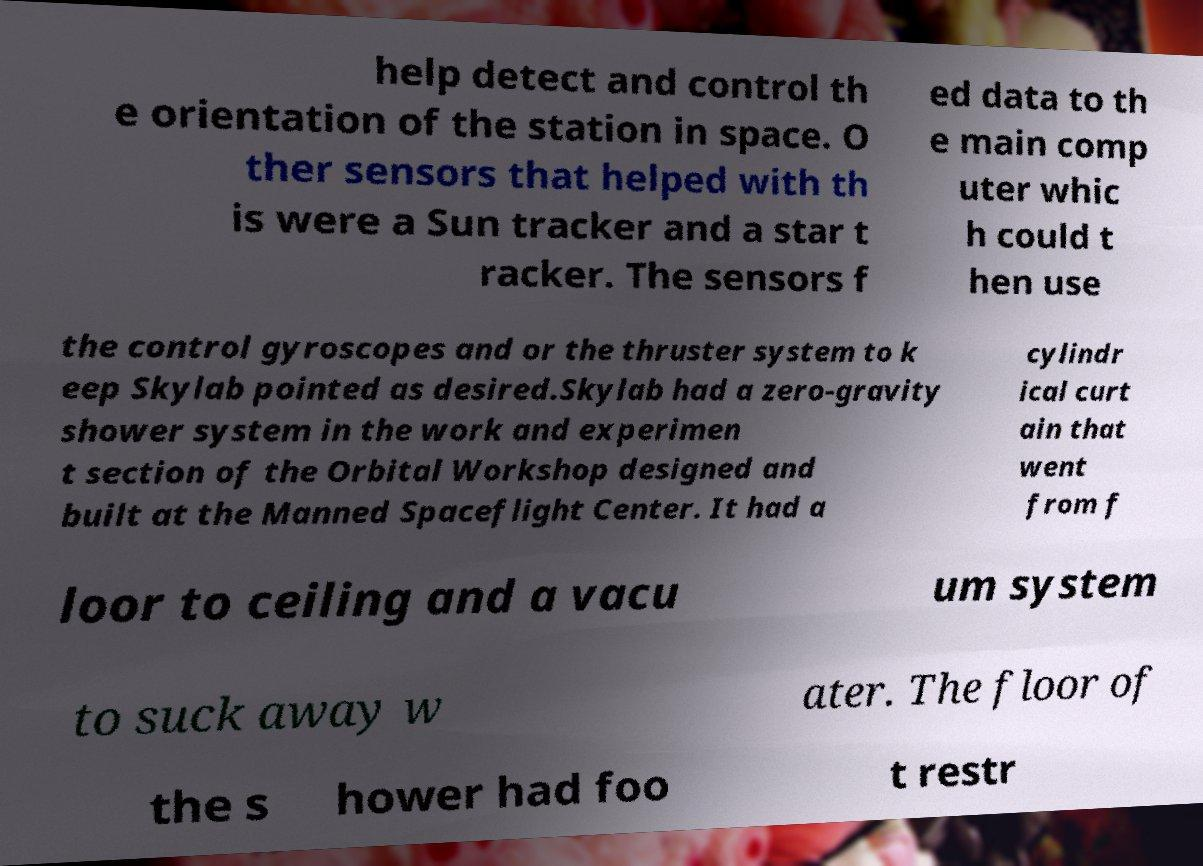I need the written content from this picture converted into text. Can you do that? help detect and control th e orientation of the station in space. O ther sensors that helped with th is were a Sun tracker and a star t racker. The sensors f ed data to th e main comp uter whic h could t hen use the control gyroscopes and or the thruster system to k eep Skylab pointed as desired.Skylab had a zero-gravity shower system in the work and experimen t section of the Orbital Workshop designed and built at the Manned Spaceflight Center. It had a cylindr ical curt ain that went from f loor to ceiling and a vacu um system to suck away w ater. The floor of the s hower had foo t restr 